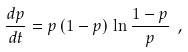Convert formula to latex. <formula><loc_0><loc_0><loc_500><loc_500>\frac { d p } { d t } = p \, ( 1 - p ) \, \ln \frac { 1 - p } { p } \ ,</formula> 